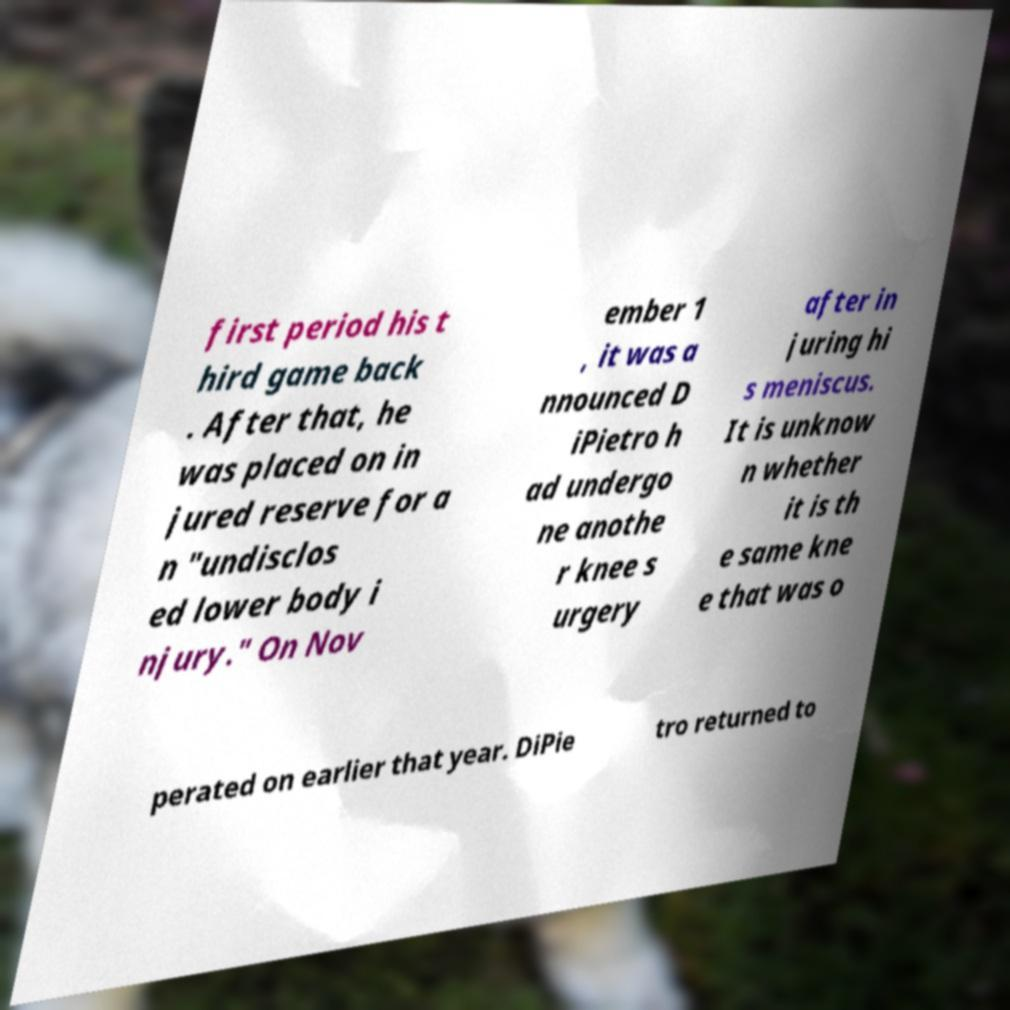Could you assist in decoding the text presented in this image and type it out clearly? first period his t hird game back . After that, he was placed on in jured reserve for a n "undisclos ed lower body i njury." On Nov ember 1 , it was a nnounced D iPietro h ad undergo ne anothe r knee s urgery after in juring hi s meniscus. It is unknow n whether it is th e same kne e that was o perated on earlier that year. DiPie tro returned to 